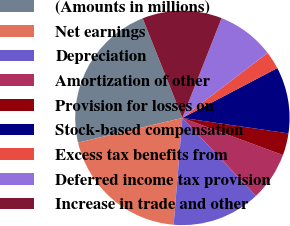Convert chart to OTSL. <chart><loc_0><loc_0><loc_500><loc_500><pie_chart><fcel>(Amounts in millions)<fcel>Net earnings<fcel>Depreciation<fcel>Amortization of other<fcel>Provision for losses on<fcel>Stock-based compensation<fcel>Excess tax benefits from<fcel>Deferred income tax provision<fcel>Increase in trade and other<nl><fcel>22.67%<fcel>20.0%<fcel>13.33%<fcel>7.33%<fcel>3.33%<fcel>10.0%<fcel>2.67%<fcel>8.67%<fcel>12.0%<nl></chart> 